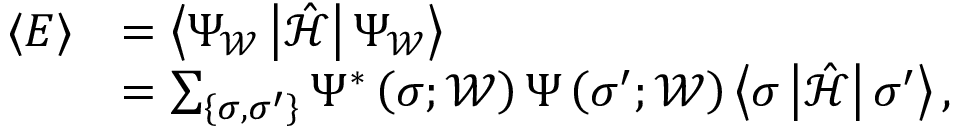<formula> <loc_0><loc_0><loc_500><loc_500>\begin{array} { r l } { \langle E \rangle } & { = \left \langle \Psi _ { \mathcal { W } } \left | \hat { \mathcal { H } } \right | \Psi _ { \mathcal { W } } \right \rangle } \\ & { = \sum _ { \left \{ \sigma , \sigma ^ { \prime } \right \} } \Psi ^ { * } \left ( \sigma ; \mathcal { W } \right ) \Psi \left ( \sigma ^ { \prime } ; \mathcal { W } \right ) \left \langle \sigma \left | \hat { \mathcal { H } } \right | \sigma ^ { \prime } \right \rangle , } \end{array}</formula> 